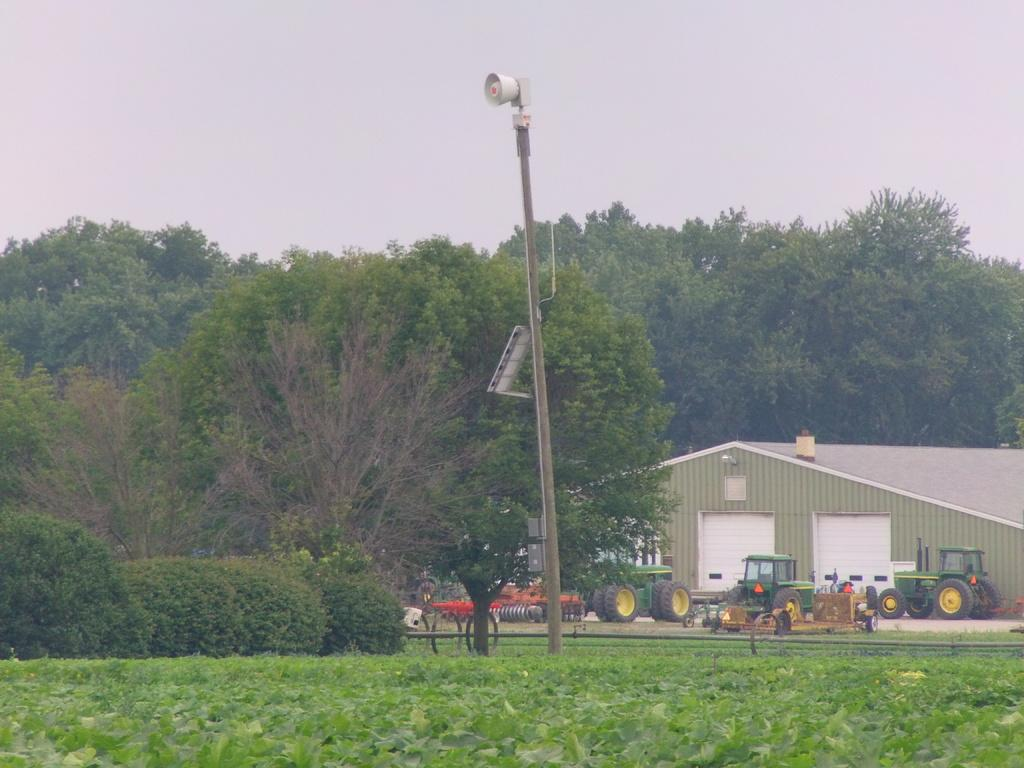What is located in the foreground of the image? In the foreground of the image, there is a pole, grass, plants, trees, a bench, and vehicles on the road. Can you describe the vegetation in the foreground of the image? The vegetation in the foreground includes grass, plants, and trees. What type of structure can be seen in the background of the image? There is a shed in the background of the image. What is visible in the sky in the background of the image? The sky is visible in the background of the image. Based on the presence of the sun and shadows, can you determine the time of day the image was taken? The image was likely taken during the day, as the sun is visible and there are shadows present. What type of jelly is being served at the party in the image? There is no party or jelly present in the image. How many teeth can be seen in the image? There are no teeth visible in the image. 